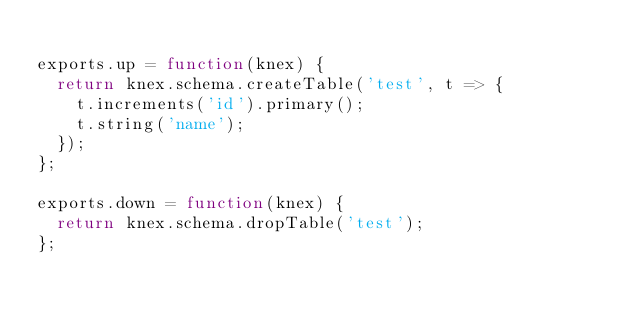Convert code to text. <code><loc_0><loc_0><loc_500><loc_500><_JavaScript_>
exports.up = function(knex) {
  return knex.schema.createTable('test', t => {
    t.increments('id').primary();
    t.string('name');
  });
};

exports.down = function(knex) {
  return knex.schema.dropTable('test');
};
</code> 